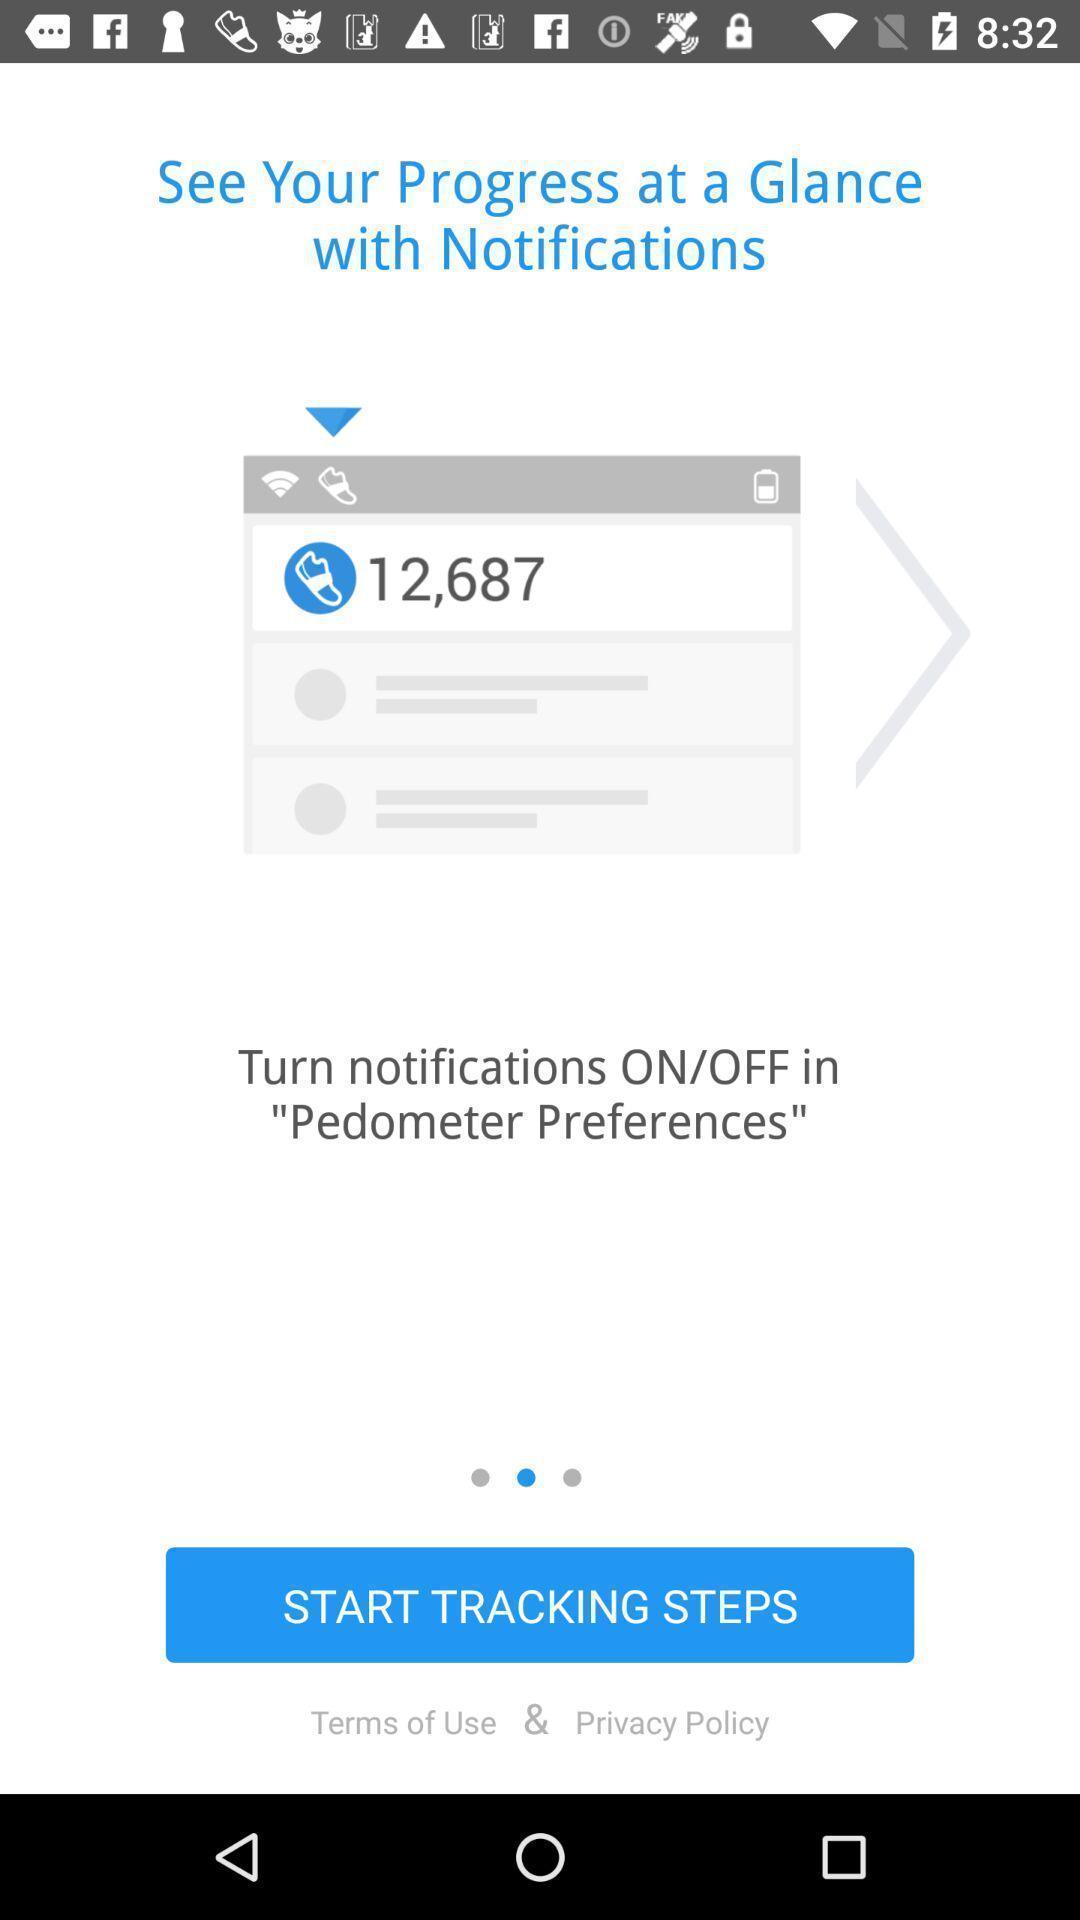What can you discern from this picture? Welcome screen of pedometer app. 